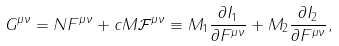Convert formula to latex. <formula><loc_0><loc_0><loc_500><loc_500>G ^ { \mu \nu } = N F ^ { \mu \nu } + c M { \mathcal { F } } ^ { \mu \nu } \equiv M _ { 1 } \frac { \partial I _ { 1 } } { \partial F ^ { \mu \nu } } + M _ { 2 } \frac { \partial I _ { 2 } } { \partial F ^ { \mu \nu } } ,</formula> 